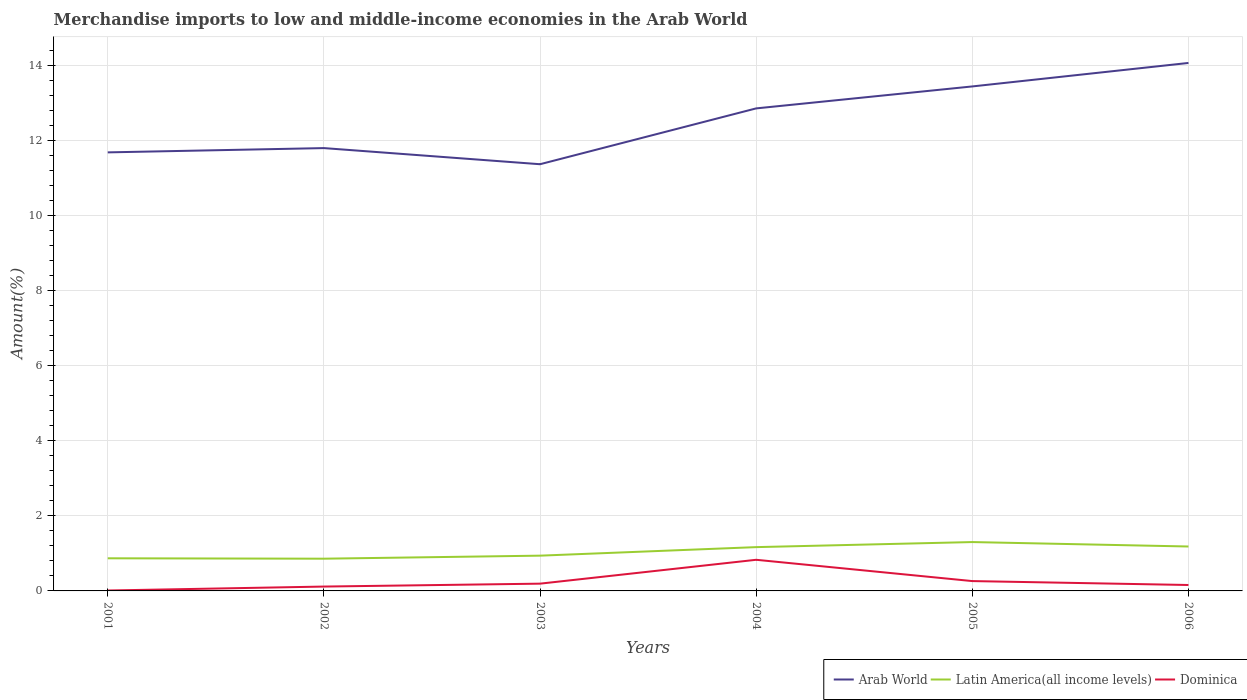How many different coloured lines are there?
Provide a short and direct response. 3. Across all years, what is the maximum percentage of amount earned from merchandise imports in Dominica?
Provide a short and direct response. 0.01. What is the total percentage of amount earned from merchandise imports in Arab World in the graph?
Provide a succinct answer. -1.49. What is the difference between the highest and the second highest percentage of amount earned from merchandise imports in Arab World?
Offer a very short reply. 2.7. What is the difference between the highest and the lowest percentage of amount earned from merchandise imports in Latin America(all income levels)?
Provide a succinct answer. 3. Is the percentage of amount earned from merchandise imports in Dominica strictly greater than the percentage of amount earned from merchandise imports in Latin America(all income levels) over the years?
Provide a short and direct response. Yes. How many years are there in the graph?
Offer a very short reply. 6. Are the values on the major ticks of Y-axis written in scientific E-notation?
Keep it short and to the point. No. Does the graph contain grids?
Your response must be concise. Yes. Where does the legend appear in the graph?
Keep it short and to the point. Bottom right. How many legend labels are there?
Provide a short and direct response. 3. How are the legend labels stacked?
Give a very brief answer. Horizontal. What is the title of the graph?
Make the answer very short. Merchandise imports to low and middle-income economies in the Arab World. What is the label or title of the Y-axis?
Offer a very short reply. Amount(%). What is the Amount(%) in Arab World in 2001?
Provide a short and direct response. 11.69. What is the Amount(%) in Latin America(all income levels) in 2001?
Provide a short and direct response. 0.87. What is the Amount(%) of Dominica in 2001?
Ensure brevity in your answer.  0.01. What is the Amount(%) in Arab World in 2002?
Keep it short and to the point. 11.8. What is the Amount(%) in Latin America(all income levels) in 2002?
Your answer should be very brief. 0.86. What is the Amount(%) of Dominica in 2002?
Provide a succinct answer. 0.12. What is the Amount(%) in Arab World in 2003?
Make the answer very short. 11.37. What is the Amount(%) in Latin America(all income levels) in 2003?
Ensure brevity in your answer.  0.94. What is the Amount(%) of Dominica in 2003?
Your answer should be compact. 0.19. What is the Amount(%) of Arab World in 2004?
Ensure brevity in your answer.  12.86. What is the Amount(%) of Latin America(all income levels) in 2004?
Provide a short and direct response. 1.17. What is the Amount(%) in Dominica in 2004?
Provide a succinct answer. 0.83. What is the Amount(%) in Arab World in 2005?
Keep it short and to the point. 13.45. What is the Amount(%) in Latin America(all income levels) in 2005?
Your answer should be very brief. 1.3. What is the Amount(%) of Dominica in 2005?
Provide a succinct answer. 0.26. What is the Amount(%) in Arab World in 2006?
Give a very brief answer. 14.07. What is the Amount(%) in Latin America(all income levels) in 2006?
Make the answer very short. 1.18. What is the Amount(%) in Dominica in 2006?
Keep it short and to the point. 0.16. Across all years, what is the maximum Amount(%) in Arab World?
Your response must be concise. 14.07. Across all years, what is the maximum Amount(%) of Latin America(all income levels)?
Provide a succinct answer. 1.3. Across all years, what is the maximum Amount(%) of Dominica?
Keep it short and to the point. 0.83. Across all years, what is the minimum Amount(%) in Arab World?
Ensure brevity in your answer.  11.37. Across all years, what is the minimum Amount(%) in Latin America(all income levels)?
Your answer should be very brief. 0.86. Across all years, what is the minimum Amount(%) of Dominica?
Ensure brevity in your answer.  0.01. What is the total Amount(%) of Arab World in the graph?
Make the answer very short. 75.24. What is the total Amount(%) in Latin America(all income levels) in the graph?
Keep it short and to the point. 6.32. What is the total Amount(%) of Dominica in the graph?
Make the answer very short. 1.57. What is the difference between the Amount(%) of Arab World in 2001 and that in 2002?
Provide a succinct answer. -0.11. What is the difference between the Amount(%) in Latin America(all income levels) in 2001 and that in 2002?
Your response must be concise. 0.01. What is the difference between the Amount(%) of Dominica in 2001 and that in 2002?
Keep it short and to the point. -0.11. What is the difference between the Amount(%) of Arab World in 2001 and that in 2003?
Offer a very short reply. 0.32. What is the difference between the Amount(%) in Latin America(all income levels) in 2001 and that in 2003?
Provide a succinct answer. -0.07. What is the difference between the Amount(%) of Dominica in 2001 and that in 2003?
Your answer should be compact. -0.18. What is the difference between the Amount(%) of Arab World in 2001 and that in 2004?
Provide a short and direct response. -1.17. What is the difference between the Amount(%) of Latin America(all income levels) in 2001 and that in 2004?
Your answer should be very brief. -0.3. What is the difference between the Amount(%) in Dominica in 2001 and that in 2004?
Offer a terse response. -0.82. What is the difference between the Amount(%) of Arab World in 2001 and that in 2005?
Offer a very short reply. -1.76. What is the difference between the Amount(%) in Latin America(all income levels) in 2001 and that in 2005?
Provide a succinct answer. -0.43. What is the difference between the Amount(%) of Dominica in 2001 and that in 2005?
Provide a short and direct response. -0.25. What is the difference between the Amount(%) of Arab World in 2001 and that in 2006?
Make the answer very short. -2.38. What is the difference between the Amount(%) of Latin America(all income levels) in 2001 and that in 2006?
Ensure brevity in your answer.  -0.31. What is the difference between the Amount(%) in Dominica in 2001 and that in 2006?
Your response must be concise. -0.15. What is the difference between the Amount(%) in Arab World in 2002 and that in 2003?
Ensure brevity in your answer.  0.43. What is the difference between the Amount(%) of Latin America(all income levels) in 2002 and that in 2003?
Your answer should be very brief. -0.08. What is the difference between the Amount(%) of Dominica in 2002 and that in 2003?
Make the answer very short. -0.08. What is the difference between the Amount(%) of Arab World in 2002 and that in 2004?
Ensure brevity in your answer.  -1.06. What is the difference between the Amount(%) of Latin America(all income levels) in 2002 and that in 2004?
Offer a terse response. -0.31. What is the difference between the Amount(%) of Dominica in 2002 and that in 2004?
Your answer should be compact. -0.71. What is the difference between the Amount(%) in Arab World in 2002 and that in 2005?
Provide a succinct answer. -1.64. What is the difference between the Amount(%) in Latin America(all income levels) in 2002 and that in 2005?
Provide a succinct answer. -0.44. What is the difference between the Amount(%) in Dominica in 2002 and that in 2005?
Offer a terse response. -0.15. What is the difference between the Amount(%) in Arab World in 2002 and that in 2006?
Ensure brevity in your answer.  -2.27. What is the difference between the Amount(%) of Latin America(all income levels) in 2002 and that in 2006?
Your response must be concise. -0.32. What is the difference between the Amount(%) of Dominica in 2002 and that in 2006?
Keep it short and to the point. -0.04. What is the difference between the Amount(%) in Arab World in 2003 and that in 2004?
Provide a short and direct response. -1.49. What is the difference between the Amount(%) of Latin America(all income levels) in 2003 and that in 2004?
Ensure brevity in your answer.  -0.23. What is the difference between the Amount(%) of Dominica in 2003 and that in 2004?
Keep it short and to the point. -0.64. What is the difference between the Amount(%) in Arab World in 2003 and that in 2005?
Make the answer very short. -2.07. What is the difference between the Amount(%) in Latin America(all income levels) in 2003 and that in 2005?
Your answer should be very brief. -0.36. What is the difference between the Amount(%) of Dominica in 2003 and that in 2005?
Your response must be concise. -0.07. What is the difference between the Amount(%) of Arab World in 2003 and that in 2006?
Keep it short and to the point. -2.7. What is the difference between the Amount(%) in Latin America(all income levels) in 2003 and that in 2006?
Provide a short and direct response. -0.24. What is the difference between the Amount(%) in Dominica in 2003 and that in 2006?
Offer a terse response. 0.04. What is the difference between the Amount(%) in Arab World in 2004 and that in 2005?
Keep it short and to the point. -0.59. What is the difference between the Amount(%) in Latin America(all income levels) in 2004 and that in 2005?
Keep it short and to the point. -0.13. What is the difference between the Amount(%) in Dominica in 2004 and that in 2005?
Ensure brevity in your answer.  0.57. What is the difference between the Amount(%) of Arab World in 2004 and that in 2006?
Offer a very short reply. -1.21. What is the difference between the Amount(%) in Latin America(all income levels) in 2004 and that in 2006?
Your answer should be very brief. -0.02. What is the difference between the Amount(%) in Dominica in 2004 and that in 2006?
Give a very brief answer. 0.67. What is the difference between the Amount(%) in Arab World in 2005 and that in 2006?
Give a very brief answer. -0.63. What is the difference between the Amount(%) in Latin America(all income levels) in 2005 and that in 2006?
Offer a terse response. 0.12. What is the difference between the Amount(%) of Dominica in 2005 and that in 2006?
Your answer should be very brief. 0.1. What is the difference between the Amount(%) in Arab World in 2001 and the Amount(%) in Latin America(all income levels) in 2002?
Ensure brevity in your answer.  10.83. What is the difference between the Amount(%) of Arab World in 2001 and the Amount(%) of Dominica in 2002?
Offer a very short reply. 11.57. What is the difference between the Amount(%) of Latin America(all income levels) in 2001 and the Amount(%) of Dominica in 2002?
Offer a terse response. 0.75. What is the difference between the Amount(%) in Arab World in 2001 and the Amount(%) in Latin America(all income levels) in 2003?
Your answer should be compact. 10.75. What is the difference between the Amount(%) in Arab World in 2001 and the Amount(%) in Dominica in 2003?
Ensure brevity in your answer.  11.49. What is the difference between the Amount(%) in Latin America(all income levels) in 2001 and the Amount(%) in Dominica in 2003?
Offer a terse response. 0.68. What is the difference between the Amount(%) in Arab World in 2001 and the Amount(%) in Latin America(all income levels) in 2004?
Give a very brief answer. 10.52. What is the difference between the Amount(%) of Arab World in 2001 and the Amount(%) of Dominica in 2004?
Ensure brevity in your answer.  10.86. What is the difference between the Amount(%) of Latin America(all income levels) in 2001 and the Amount(%) of Dominica in 2004?
Ensure brevity in your answer.  0.04. What is the difference between the Amount(%) in Arab World in 2001 and the Amount(%) in Latin America(all income levels) in 2005?
Provide a succinct answer. 10.39. What is the difference between the Amount(%) of Arab World in 2001 and the Amount(%) of Dominica in 2005?
Ensure brevity in your answer.  11.43. What is the difference between the Amount(%) of Latin America(all income levels) in 2001 and the Amount(%) of Dominica in 2005?
Your answer should be very brief. 0.61. What is the difference between the Amount(%) in Arab World in 2001 and the Amount(%) in Latin America(all income levels) in 2006?
Keep it short and to the point. 10.5. What is the difference between the Amount(%) of Arab World in 2001 and the Amount(%) of Dominica in 2006?
Provide a short and direct response. 11.53. What is the difference between the Amount(%) in Latin America(all income levels) in 2001 and the Amount(%) in Dominica in 2006?
Offer a terse response. 0.71. What is the difference between the Amount(%) of Arab World in 2002 and the Amount(%) of Latin America(all income levels) in 2003?
Provide a succinct answer. 10.86. What is the difference between the Amount(%) in Arab World in 2002 and the Amount(%) in Dominica in 2003?
Make the answer very short. 11.61. What is the difference between the Amount(%) of Latin America(all income levels) in 2002 and the Amount(%) of Dominica in 2003?
Offer a terse response. 0.67. What is the difference between the Amount(%) in Arab World in 2002 and the Amount(%) in Latin America(all income levels) in 2004?
Ensure brevity in your answer.  10.64. What is the difference between the Amount(%) in Arab World in 2002 and the Amount(%) in Dominica in 2004?
Provide a short and direct response. 10.97. What is the difference between the Amount(%) of Latin America(all income levels) in 2002 and the Amount(%) of Dominica in 2004?
Offer a very short reply. 0.03. What is the difference between the Amount(%) of Arab World in 2002 and the Amount(%) of Latin America(all income levels) in 2005?
Offer a very short reply. 10.5. What is the difference between the Amount(%) in Arab World in 2002 and the Amount(%) in Dominica in 2005?
Your answer should be compact. 11.54. What is the difference between the Amount(%) of Latin America(all income levels) in 2002 and the Amount(%) of Dominica in 2005?
Offer a terse response. 0.6. What is the difference between the Amount(%) in Arab World in 2002 and the Amount(%) in Latin America(all income levels) in 2006?
Make the answer very short. 10.62. What is the difference between the Amount(%) in Arab World in 2002 and the Amount(%) in Dominica in 2006?
Provide a short and direct response. 11.64. What is the difference between the Amount(%) of Latin America(all income levels) in 2002 and the Amount(%) of Dominica in 2006?
Offer a terse response. 0.7. What is the difference between the Amount(%) in Arab World in 2003 and the Amount(%) in Latin America(all income levels) in 2004?
Keep it short and to the point. 10.21. What is the difference between the Amount(%) of Arab World in 2003 and the Amount(%) of Dominica in 2004?
Keep it short and to the point. 10.54. What is the difference between the Amount(%) in Latin America(all income levels) in 2003 and the Amount(%) in Dominica in 2004?
Your answer should be very brief. 0.11. What is the difference between the Amount(%) in Arab World in 2003 and the Amount(%) in Latin America(all income levels) in 2005?
Offer a very short reply. 10.07. What is the difference between the Amount(%) in Arab World in 2003 and the Amount(%) in Dominica in 2005?
Offer a very short reply. 11.11. What is the difference between the Amount(%) in Latin America(all income levels) in 2003 and the Amount(%) in Dominica in 2005?
Ensure brevity in your answer.  0.68. What is the difference between the Amount(%) in Arab World in 2003 and the Amount(%) in Latin America(all income levels) in 2006?
Give a very brief answer. 10.19. What is the difference between the Amount(%) of Arab World in 2003 and the Amount(%) of Dominica in 2006?
Your answer should be very brief. 11.22. What is the difference between the Amount(%) of Latin America(all income levels) in 2003 and the Amount(%) of Dominica in 2006?
Your answer should be very brief. 0.78. What is the difference between the Amount(%) in Arab World in 2004 and the Amount(%) in Latin America(all income levels) in 2005?
Provide a succinct answer. 11.56. What is the difference between the Amount(%) of Arab World in 2004 and the Amount(%) of Dominica in 2005?
Ensure brevity in your answer.  12.6. What is the difference between the Amount(%) in Latin America(all income levels) in 2004 and the Amount(%) in Dominica in 2005?
Offer a very short reply. 0.91. What is the difference between the Amount(%) of Arab World in 2004 and the Amount(%) of Latin America(all income levels) in 2006?
Your response must be concise. 11.68. What is the difference between the Amount(%) of Arab World in 2004 and the Amount(%) of Dominica in 2006?
Your answer should be very brief. 12.7. What is the difference between the Amount(%) of Latin America(all income levels) in 2004 and the Amount(%) of Dominica in 2006?
Provide a short and direct response. 1.01. What is the difference between the Amount(%) in Arab World in 2005 and the Amount(%) in Latin America(all income levels) in 2006?
Your answer should be compact. 12.26. What is the difference between the Amount(%) in Arab World in 2005 and the Amount(%) in Dominica in 2006?
Ensure brevity in your answer.  13.29. What is the difference between the Amount(%) of Latin America(all income levels) in 2005 and the Amount(%) of Dominica in 2006?
Give a very brief answer. 1.14. What is the average Amount(%) in Arab World per year?
Your answer should be very brief. 12.54. What is the average Amount(%) in Latin America(all income levels) per year?
Make the answer very short. 1.05. What is the average Amount(%) of Dominica per year?
Ensure brevity in your answer.  0.26. In the year 2001, what is the difference between the Amount(%) of Arab World and Amount(%) of Latin America(all income levels)?
Provide a short and direct response. 10.82. In the year 2001, what is the difference between the Amount(%) of Arab World and Amount(%) of Dominica?
Your response must be concise. 11.68. In the year 2001, what is the difference between the Amount(%) in Latin America(all income levels) and Amount(%) in Dominica?
Offer a terse response. 0.86. In the year 2002, what is the difference between the Amount(%) in Arab World and Amount(%) in Latin America(all income levels)?
Keep it short and to the point. 10.94. In the year 2002, what is the difference between the Amount(%) of Arab World and Amount(%) of Dominica?
Your answer should be very brief. 11.69. In the year 2002, what is the difference between the Amount(%) of Latin America(all income levels) and Amount(%) of Dominica?
Offer a terse response. 0.74. In the year 2003, what is the difference between the Amount(%) of Arab World and Amount(%) of Latin America(all income levels)?
Offer a terse response. 10.43. In the year 2003, what is the difference between the Amount(%) in Arab World and Amount(%) in Dominica?
Your answer should be very brief. 11.18. In the year 2003, what is the difference between the Amount(%) of Latin America(all income levels) and Amount(%) of Dominica?
Your response must be concise. 0.75. In the year 2004, what is the difference between the Amount(%) of Arab World and Amount(%) of Latin America(all income levels)?
Give a very brief answer. 11.69. In the year 2004, what is the difference between the Amount(%) in Arab World and Amount(%) in Dominica?
Provide a short and direct response. 12.03. In the year 2004, what is the difference between the Amount(%) in Latin America(all income levels) and Amount(%) in Dominica?
Offer a terse response. 0.34. In the year 2005, what is the difference between the Amount(%) of Arab World and Amount(%) of Latin America(all income levels)?
Offer a very short reply. 12.14. In the year 2005, what is the difference between the Amount(%) of Arab World and Amount(%) of Dominica?
Keep it short and to the point. 13.18. In the year 2005, what is the difference between the Amount(%) in Latin America(all income levels) and Amount(%) in Dominica?
Offer a terse response. 1.04. In the year 2006, what is the difference between the Amount(%) in Arab World and Amount(%) in Latin America(all income levels)?
Provide a succinct answer. 12.89. In the year 2006, what is the difference between the Amount(%) of Arab World and Amount(%) of Dominica?
Your answer should be very brief. 13.91. What is the ratio of the Amount(%) of Arab World in 2001 to that in 2002?
Your response must be concise. 0.99. What is the ratio of the Amount(%) in Latin America(all income levels) in 2001 to that in 2002?
Provide a succinct answer. 1.01. What is the ratio of the Amount(%) of Dominica in 2001 to that in 2002?
Offer a terse response. 0.09. What is the ratio of the Amount(%) in Arab World in 2001 to that in 2003?
Ensure brevity in your answer.  1.03. What is the ratio of the Amount(%) of Latin America(all income levels) in 2001 to that in 2003?
Your response must be concise. 0.93. What is the ratio of the Amount(%) in Dominica in 2001 to that in 2003?
Ensure brevity in your answer.  0.06. What is the ratio of the Amount(%) of Arab World in 2001 to that in 2004?
Offer a terse response. 0.91. What is the ratio of the Amount(%) of Latin America(all income levels) in 2001 to that in 2004?
Provide a short and direct response. 0.74. What is the ratio of the Amount(%) of Dominica in 2001 to that in 2004?
Provide a short and direct response. 0.01. What is the ratio of the Amount(%) in Arab World in 2001 to that in 2005?
Offer a terse response. 0.87. What is the ratio of the Amount(%) in Latin America(all income levels) in 2001 to that in 2005?
Offer a terse response. 0.67. What is the ratio of the Amount(%) of Dominica in 2001 to that in 2005?
Your answer should be very brief. 0.04. What is the ratio of the Amount(%) of Arab World in 2001 to that in 2006?
Your answer should be very brief. 0.83. What is the ratio of the Amount(%) of Latin America(all income levels) in 2001 to that in 2006?
Your response must be concise. 0.73. What is the ratio of the Amount(%) of Dominica in 2001 to that in 2006?
Offer a terse response. 0.07. What is the ratio of the Amount(%) of Arab World in 2002 to that in 2003?
Ensure brevity in your answer.  1.04. What is the ratio of the Amount(%) of Latin America(all income levels) in 2002 to that in 2003?
Keep it short and to the point. 0.91. What is the ratio of the Amount(%) in Dominica in 2002 to that in 2003?
Provide a succinct answer. 0.6. What is the ratio of the Amount(%) in Arab World in 2002 to that in 2004?
Keep it short and to the point. 0.92. What is the ratio of the Amount(%) of Latin America(all income levels) in 2002 to that in 2004?
Your response must be concise. 0.74. What is the ratio of the Amount(%) in Dominica in 2002 to that in 2004?
Ensure brevity in your answer.  0.14. What is the ratio of the Amount(%) of Arab World in 2002 to that in 2005?
Your answer should be compact. 0.88. What is the ratio of the Amount(%) in Latin America(all income levels) in 2002 to that in 2005?
Your response must be concise. 0.66. What is the ratio of the Amount(%) of Dominica in 2002 to that in 2005?
Your response must be concise. 0.44. What is the ratio of the Amount(%) in Arab World in 2002 to that in 2006?
Offer a terse response. 0.84. What is the ratio of the Amount(%) of Latin America(all income levels) in 2002 to that in 2006?
Provide a succinct answer. 0.73. What is the ratio of the Amount(%) in Dominica in 2002 to that in 2006?
Your response must be concise. 0.74. What is the ratio of the Amount(%) in Arab World in 2003 to that in 2004?
Give a very brief answer. 0.88. What is the ratio of the Amount(%) of Latin America(all income levels) in 2003 to that in 2004?
Provide a short and direct response. 0.81. What is the ratio of the Amount(%) in Dominica in 2003 to that in 2004?
Give a very brief answer. 0.23. What is the ratio of the Amount(%) of Arab World in 2003 to that in 2005?
Your answer should be compact. 0.85. What is the ratio of the Amount(%) in Latin America(all income levels) in 2003 to that in 2005?
Give a very brief answer. 0.72. What is the ratio of the Amount(%) in Dominica in 2003 to that in 2005?
Ensure brevity in your answer.  0.74. What is the ratio of the Amount(%) in Arab World in 2003 to that in 2006?
Your answer should be compact. 0.81. What is the ratio of the Amount(%) in Latin America(all income levels) in 2003 to that in 2006?
Offer a terse response. 0.79. What is the ratio of the Amount(%) in Dominica in 2003 to that in 2006?
Your answer should be compact. 1.23. What is the ratio of the Amount(%) of Arab World in 2004 to that in 2005?
Your answer should be compact. 0.96. What is the ratio of the Amount(%) in Latin America(all income levels) in 2004 to that in 2005?
Provide a short and direct response. 0.9. What is the ratio of the Amount(%) in Dominica in 2004 to that in 2005?
Offer a terse response. 3.17. What is the ratio of the Amount(%) in Arab World in 2004 to that in 2006?
Offer a very short reply. 0.91. What is the ratio of the Amount(%) in Latin America(all income levels) in 2004 to that in 2006?
Your answer should be very brief. 0.99. What is the ratio of the Amount(%) of Dominica in 2004 to that in 2006?
Offer a very short reply. 5.25. What is the ratio of the Amount(%) of Arab World in 2005 to that in 2006?
Your answer should be very brief. 0.96. What is the ratio of the Amount(%) in Latin America(all income levels) in 2005 to that in 2006?
Provide a succinct answer. 1.1. What is the ratio of the Amount(%) in Dominica in 2005 to that in 2006?
Ensure brevity in your answer.  1.66. What is the difference between the highest and the second highest Amount(%) in Arab World?
Provide a succinct answer. 0.63. What is the difference between the highest and the second highest Amount(%) of Latin America(all income levels)?
Offer a terse response. 0.12. What is the difference between the highest and the second highest Amount(%) of Dominica?
Offer a very short reply. 0.57. What is the difference between the highest and the lowest Amount(%) of Arab World?
Provide a short and direct response. 2.7. What is the difference between the highest and the lowest Amount(%) of Latin America(all income levels)?
Offer a very short reply. 0.44. What is the difference between the highest and the lowest Amount(%) in Dominica?
Provide a short and direct response. 0.82. 